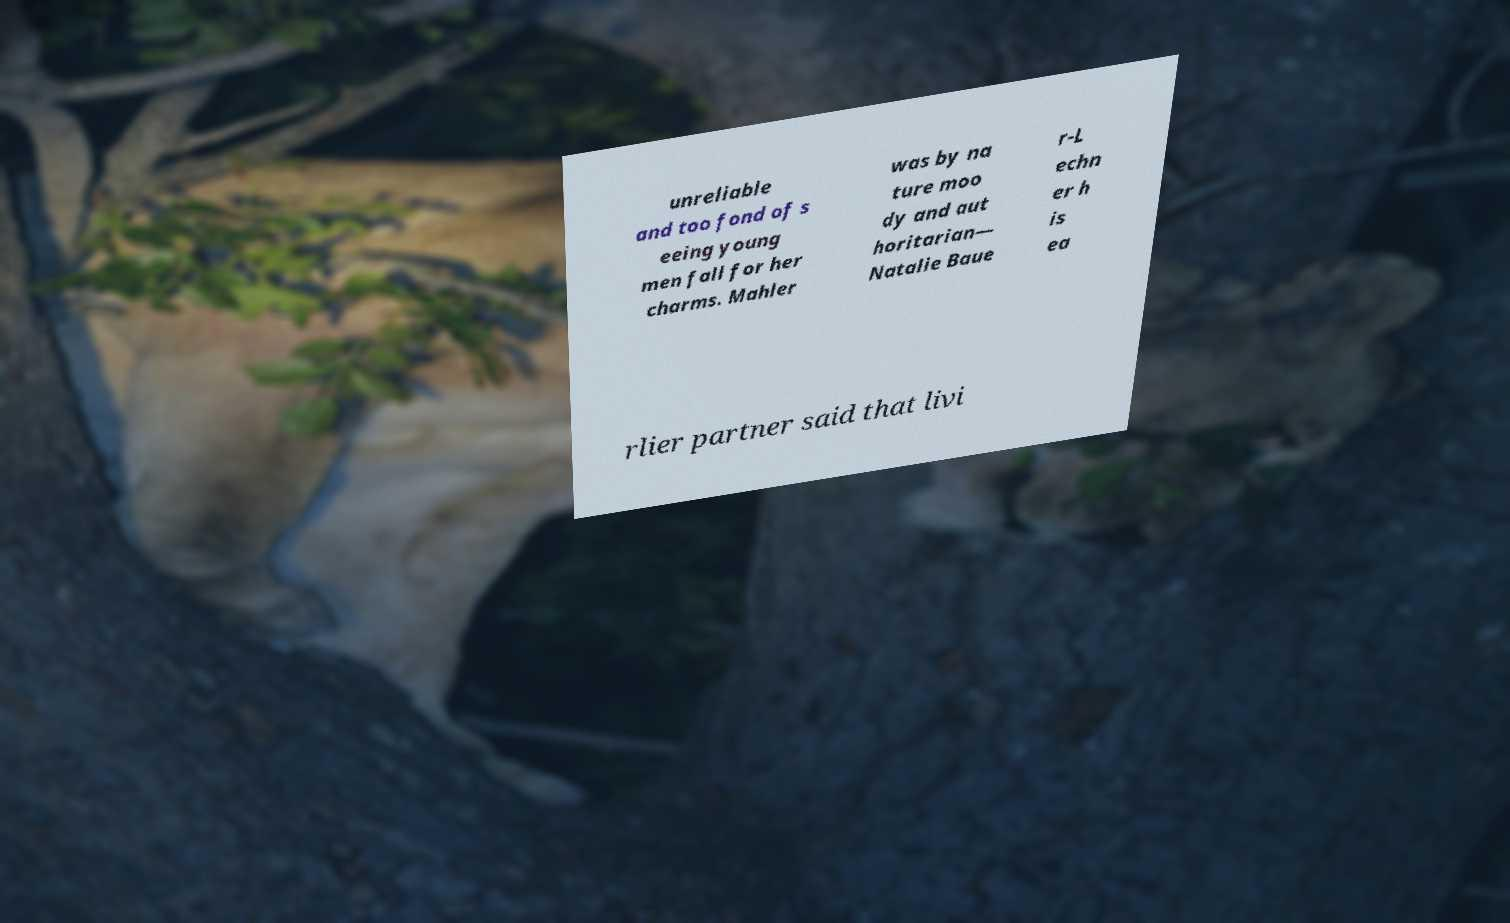Please identify and transcribe the text found in this image. unreliable and too fond of s eeing young men fall for her charms. Mahler was by na ture moo dy and aut horitarian— Natalie Baue r-L echn er h is ea rlier partner said that livi 